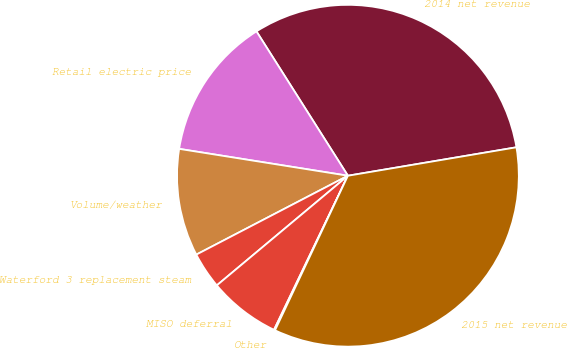Convert chart. <chart><loc_0><loc_0><loc_500><loc_500><pie_chart><fcel>2014 net revenue<fcel>Retail electric price<fcel>Volume/weather<fcel>Waterford 3 replacement steam<fcel>MISO deferral<fcel>Other<fcel>2015 net revenue<nl><fcel>31.33%<fcel>13.5%<fcel>10.15%<fcel>3.45%<fcel>6.8%<fcel>0.1%<fcel>34.68%<nl></chart> 